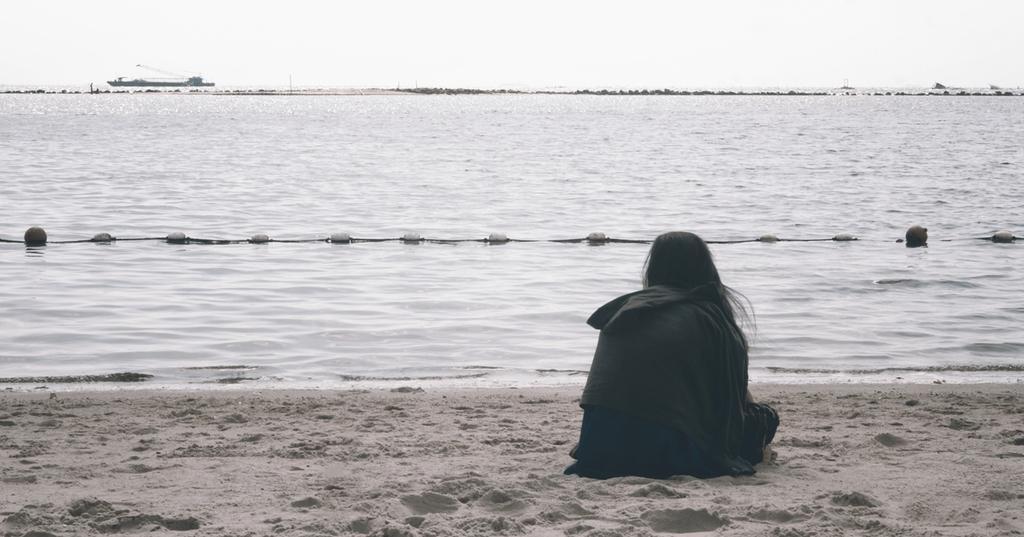Please provide a concise description of this image. This is a beach. Here I can see a person sitting on the ground facing towards the back side. In the middle of the image I can see the water. In the background there is a boat and some trees. At the top of the image I can see the sky. 